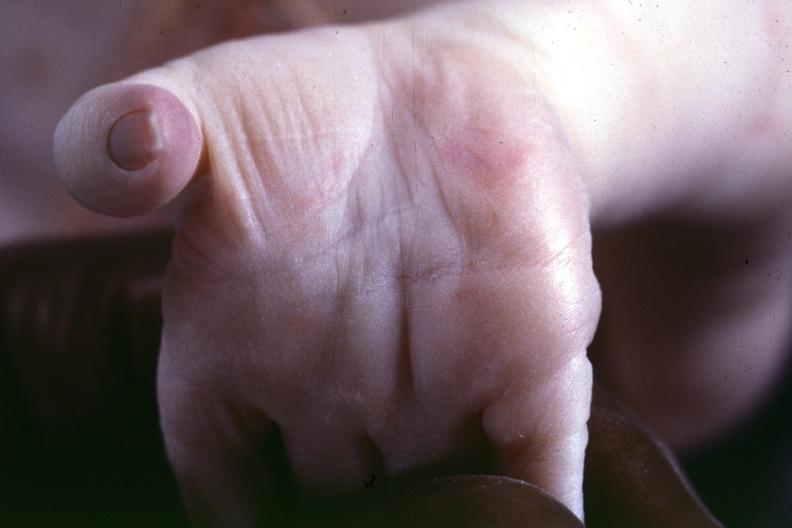s lateral view a simian crease suspect?
Answer the question using a single word or phrase. No 